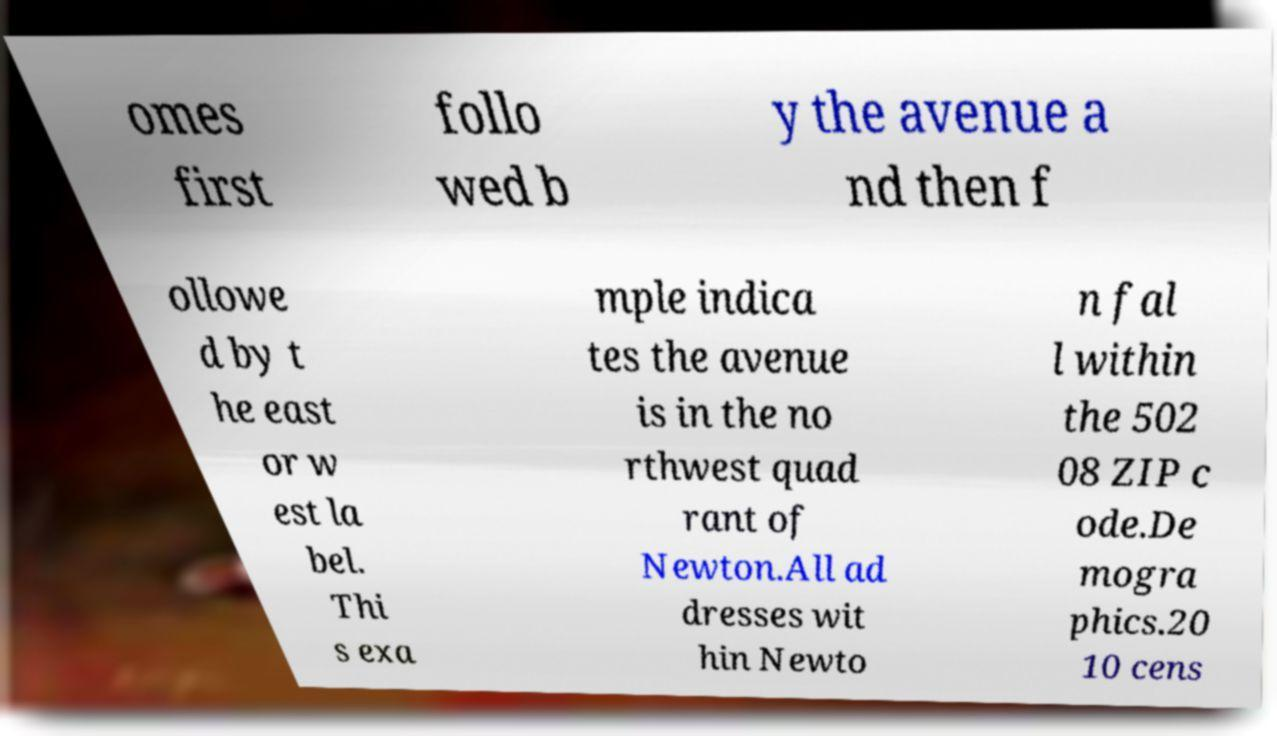Please read and relay the text visible in this image. What does it say? omes first follo wed b y the avenue a nd then f ollowe d by t he east or w est la bel. Thi s exa mple indica tes the avenue is in the no rthwest quad rant of Newton.All ad dresses wit hin Newto n fal l within the 502 08 ZIP c ode.De mogra phics.20 10 cens 